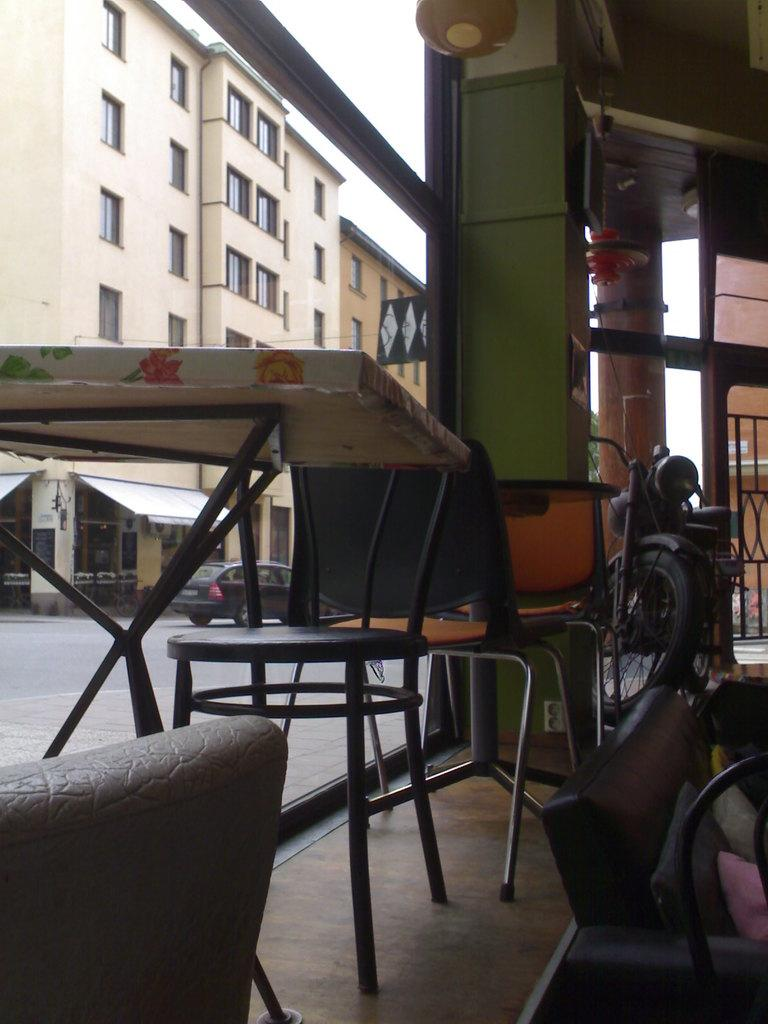What type of furniture is present in the image? There is a table and a chair in the image. What type of structure can be seen in the image? There is a building in the image. What mode of transportation is parked in the image? There is a bike parked in the image. What type of stone is used to create the building in the image? There is no information about the type of stone used to create the building in the image. 